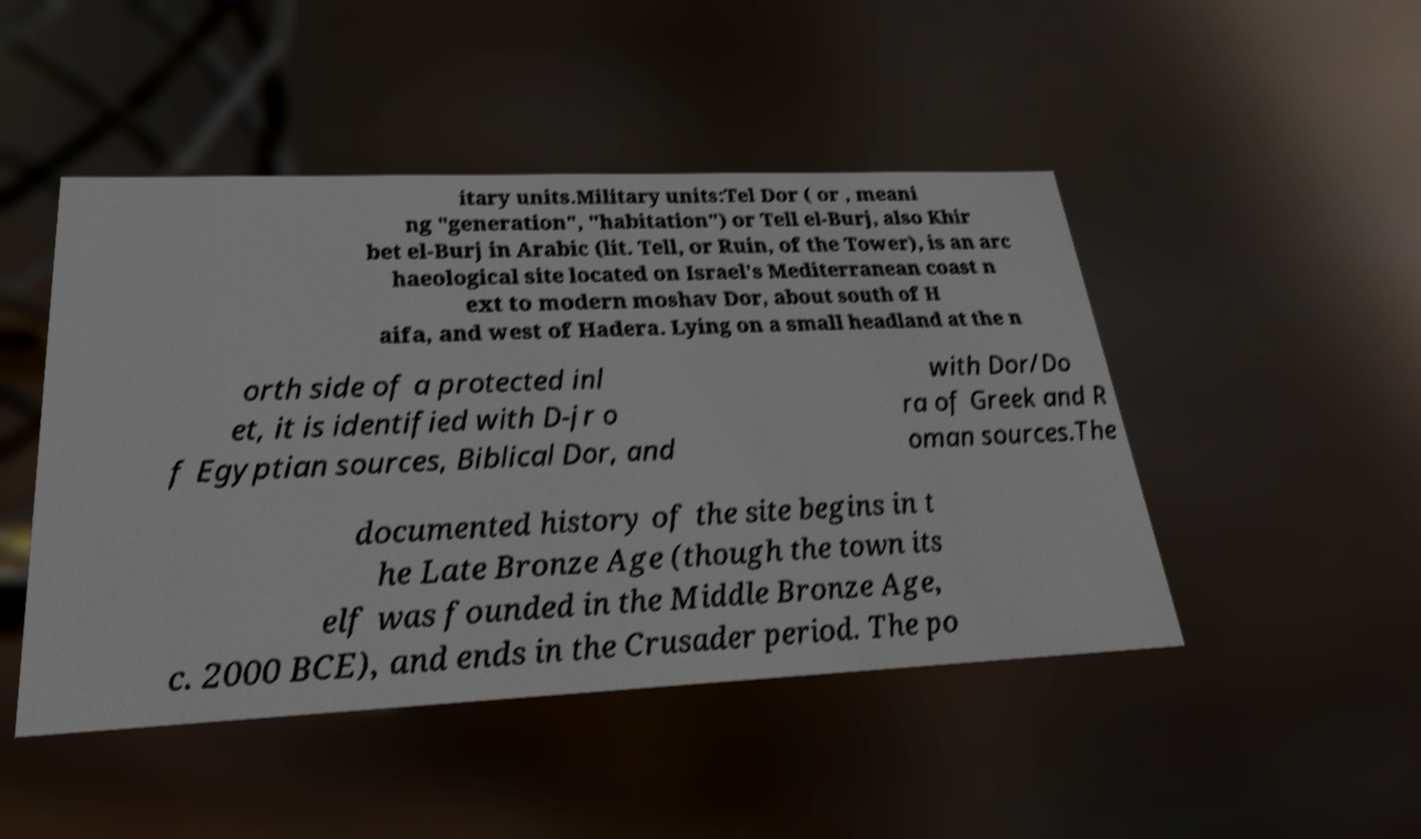Please read and relay the text visible in this image. What does it say? itary units.Military units:Tel Dor ( or , meani ng "generation", "habitation") or Tell el-Burj, also Khir bet el-Burj in Arabic (lit. Tell, or Ruin, of the Tower), is an arc haeological site located on Israel's Mediterranean coast n ext to modern moshav Dor, about south of H aifa, and west of Hadera. Lying on a small headland at the n orth side of a protected inl et, it is identified with D-jr o f Egyptian sources, Biblical Dor, and with Dor/Do ra of Greek and R oman sources.The documented history of the site begins in t he Late Bronze Age (though the town its elf was founded in the Middle Bronze Age, c. 2000 BCE), and ends in the Crusader period. The po 